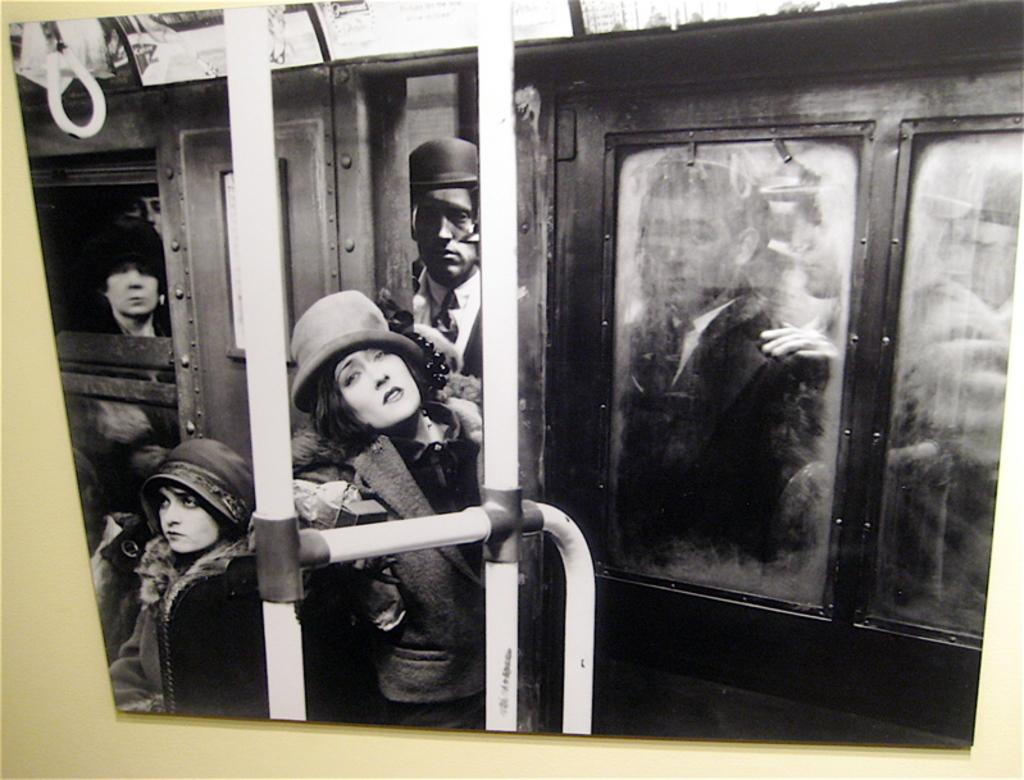What is hanging on the wall in the image? There is a photograph on the wall in the image. What is depicted in the photograph? The photograph contains people who are in a train. Can you describe the gender of the people in the photograph? There are men and women in the photograph. What type of jam is being spread on the apple in the image? There is no jam or apple present in the image; it only features a photograph of people in a train. 